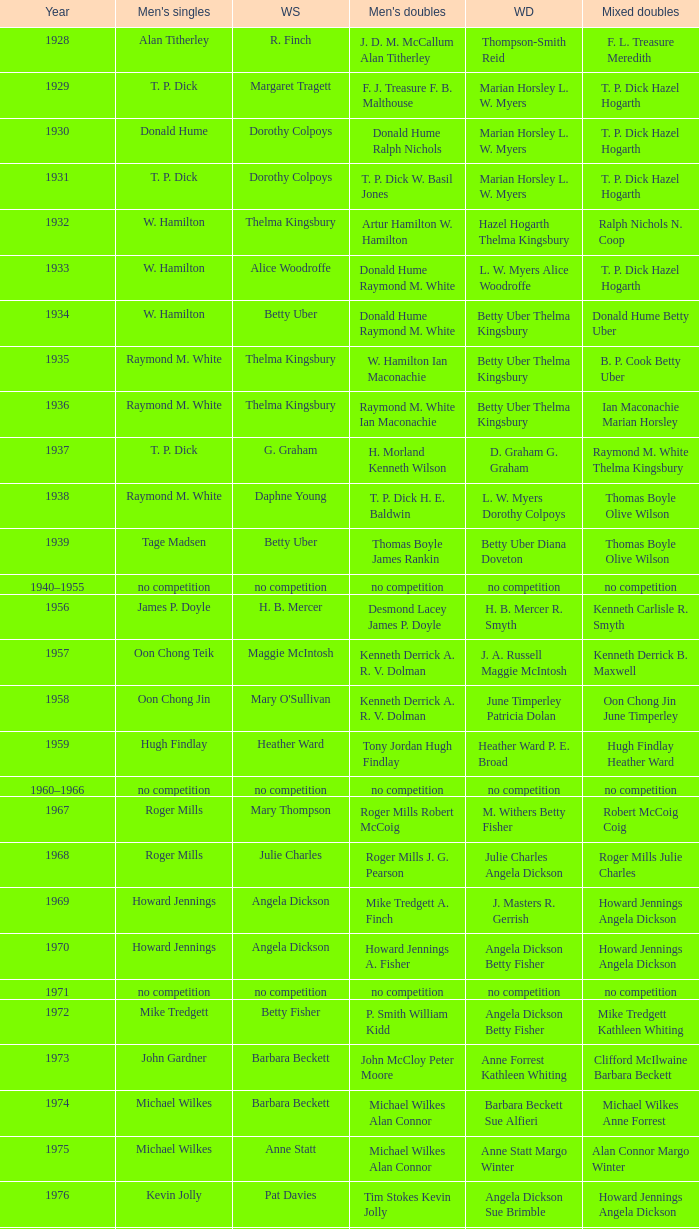Who won the Women's doubles in the year that Jesper Knudsen Nettie Nielsen won the Mixed doubles? Karen Beckman Sara Halsall. 